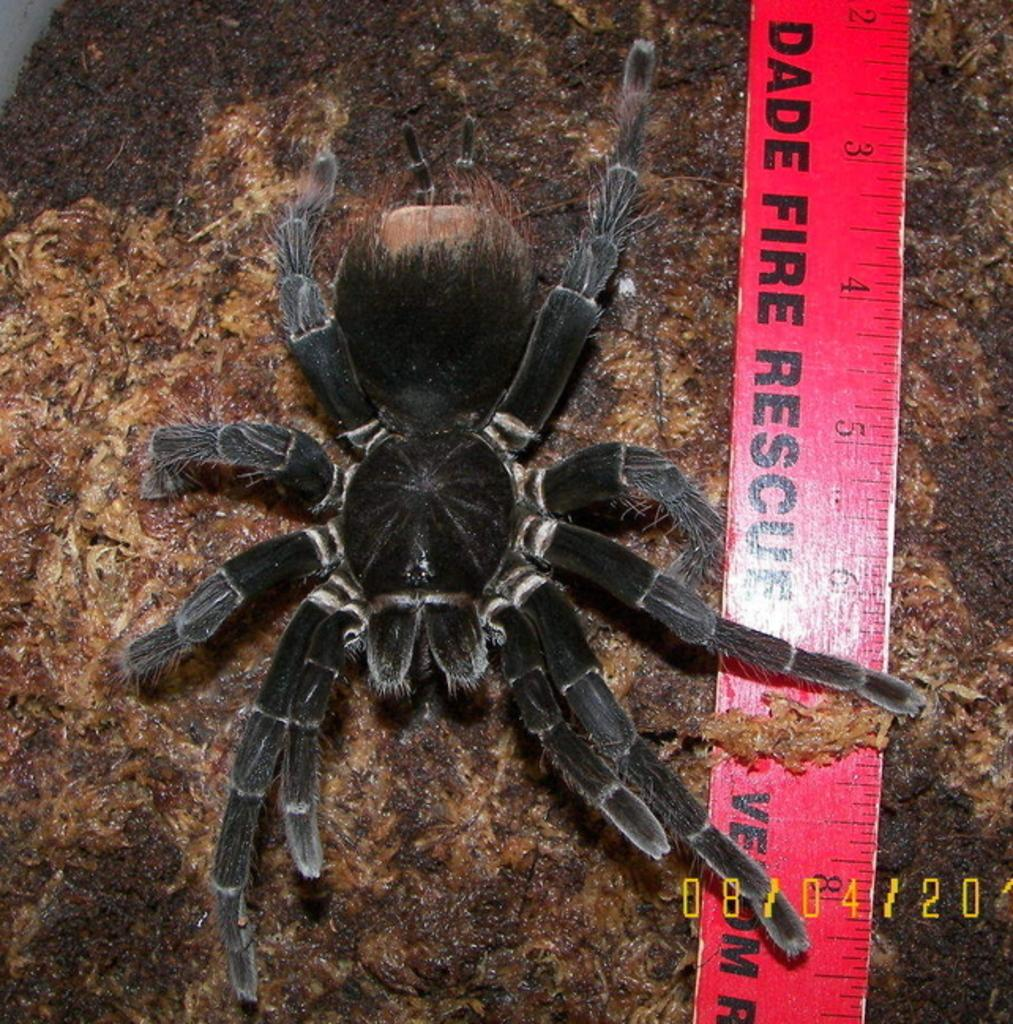What is the main subject of the picture? The main subject of the picture is a spider. What other objects can be seen in the picture? There is a measuring scale with text and text at the bottom right corner of the picture. What type of trade is being conducted in the picture? There is no trade being conducted in the picture; it features a spider and other objects. How much money is visible in the picture? There is no money visible in the picture. 